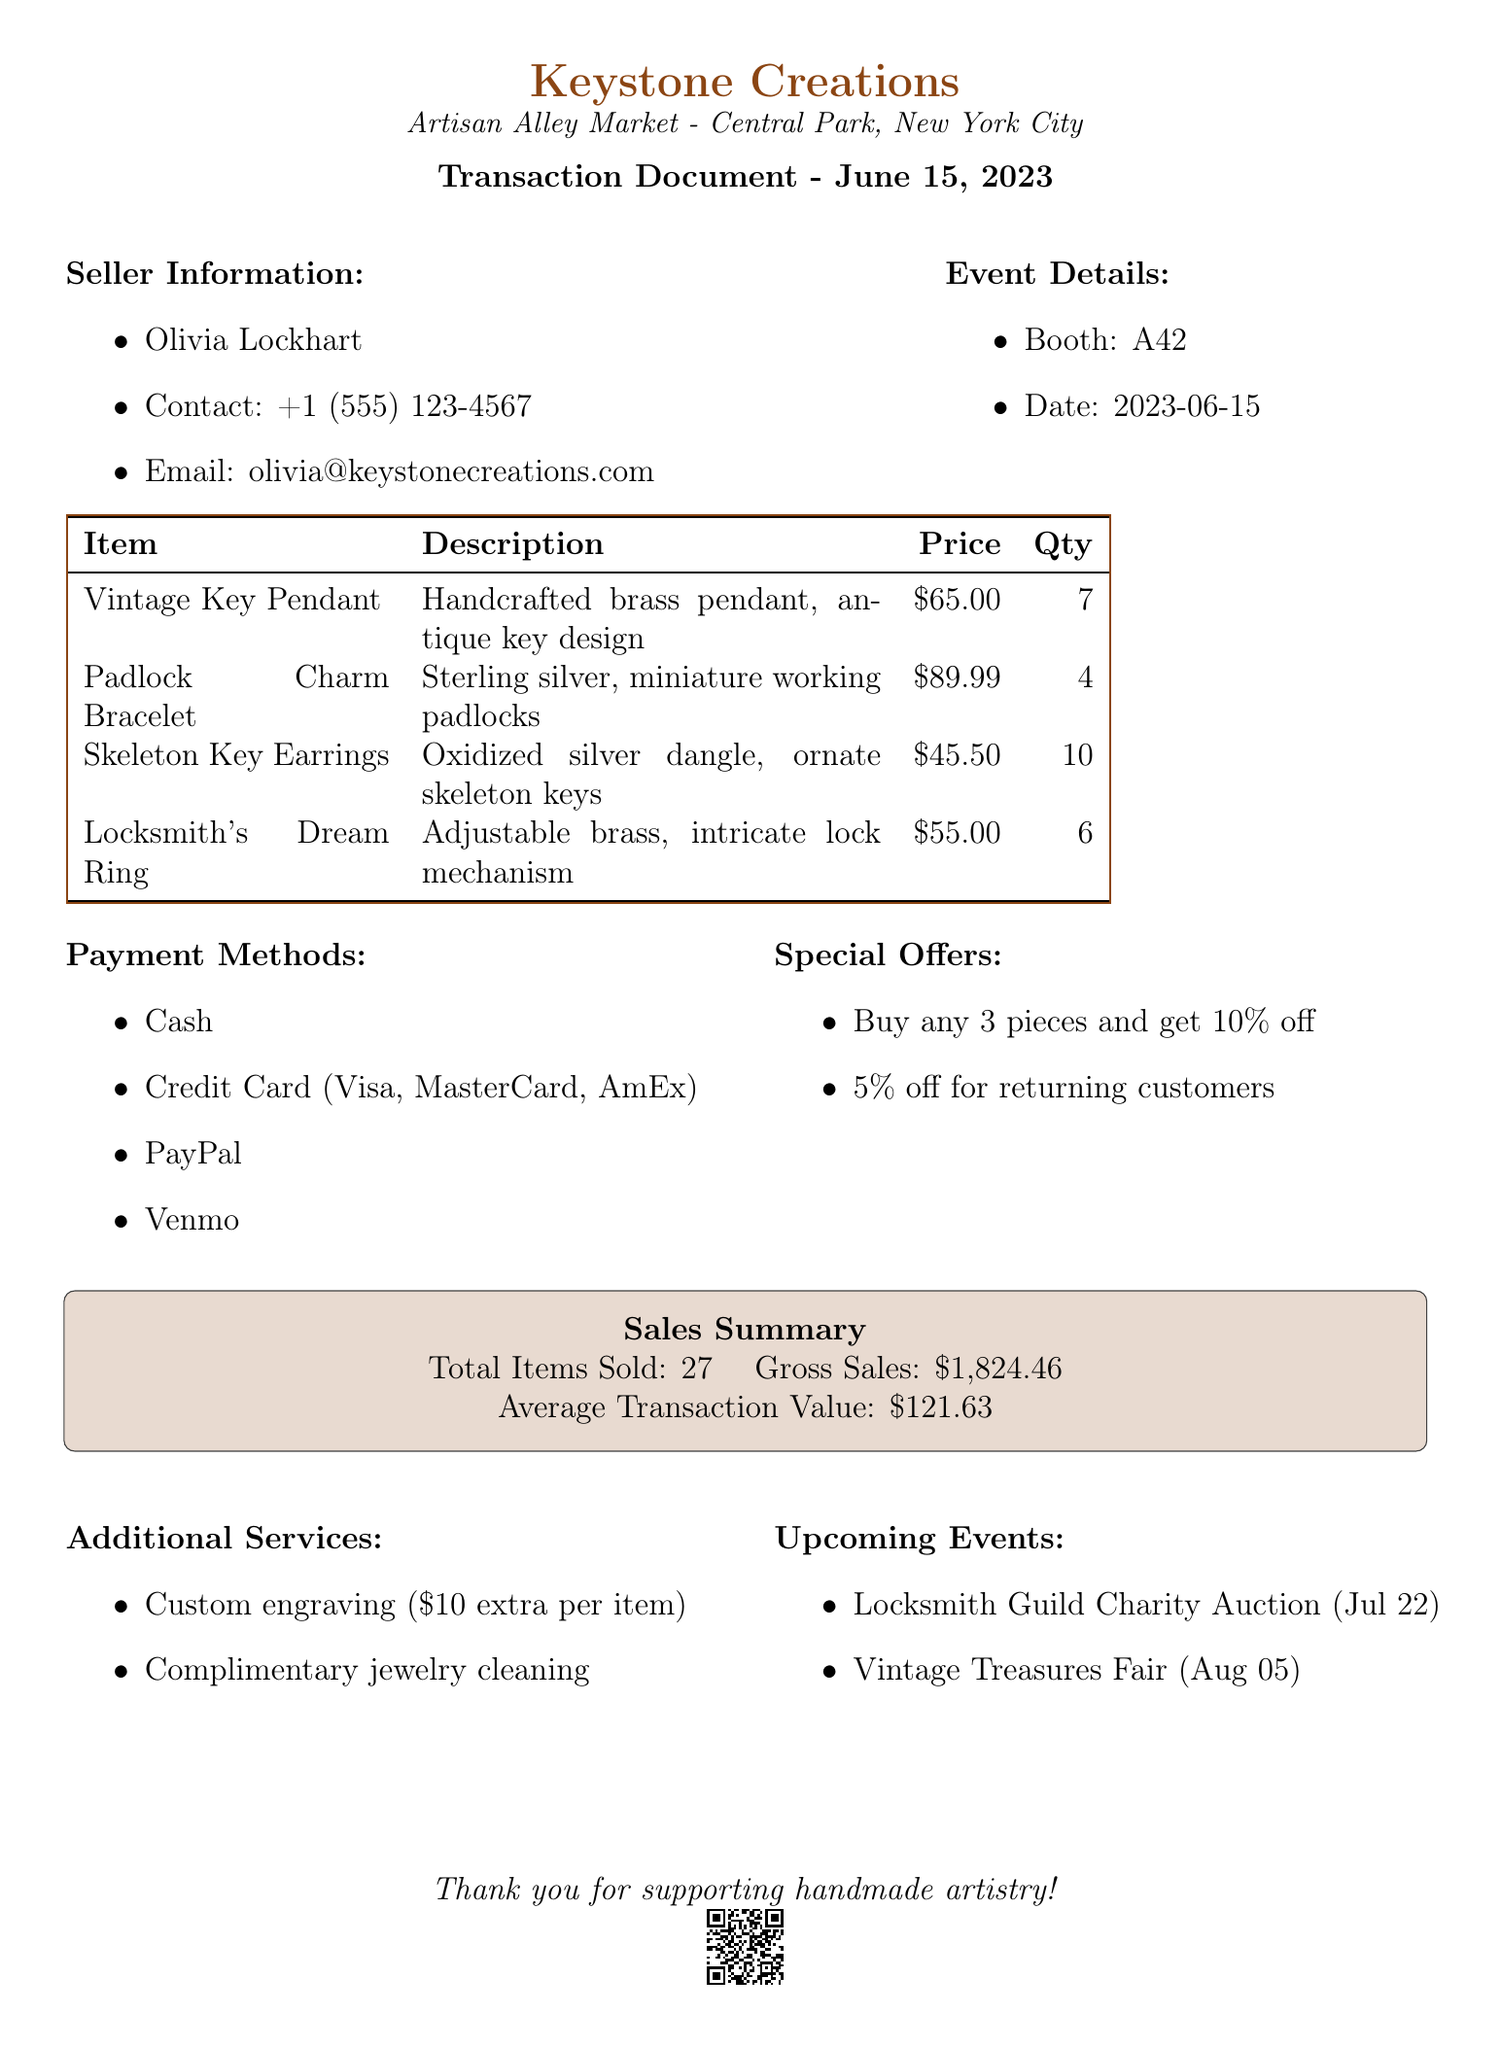What is the name of the seller? The seller's name is listed in the document under seller information.
Answer: Olivia Lockhart What is the booth number? The booth number is mentioned in the event details section of the document.
Answer: A42 What is the price of the Skeleton Key Earrings? The price can be found in the product list under the corresponding item.
Answer: 45.50 How many Vintage Key Pendant Necklaces were sold? The quantity sold can be found in the product list for that specific item.
Answer: 7 What is the total gross sales amount? The gross sales total is provided in the sales summary section of the document.
Answer: 1824.46 What special offer is available for returning customers? The document lists the special offers available to customers.
Answer: 5% off for previous customers What additional service is offered for jewelry cleaning? The additional services section specifies what is offered for cleaning purchases.
Answer: Complimentary cleaning What type of wrapping is used for gift packaging? The type of gift wrap is listed under packaging in the document.
Answer: Vintage map paper wrap with wax seal How many items were sold in total? The total number of items sold is mentioned in the sales summary section.
Answer: 27 What is the name of the upcoming event on July 22? The upcoming events listed include detailed names and dates of events.
Answer: Locksmith Guild Charity Auction 